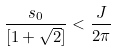Convert formula to latex. <formula><loc_0><loc_0><loc_500><loc_500>\frac { s _ { 0 } } { [ 1 + \sqrt { 2 } ] } < \frac { J } { 2 { \pi } }</formula> 